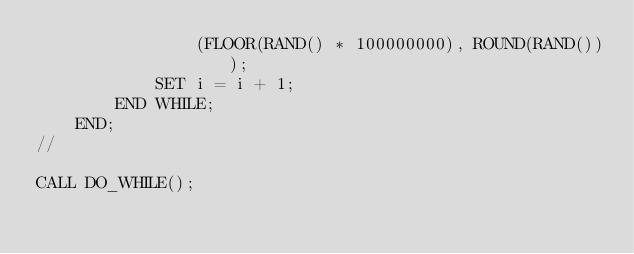<code> <loc_0><loc_0><loc_500><loc_500><_SQL_>                (FLOOR(RAND() * 100000000), ROUND(RAND()));
            SET i = i + 1;
        END WHILE;
    END;
//

CALL DO_WHILE();
</code> 